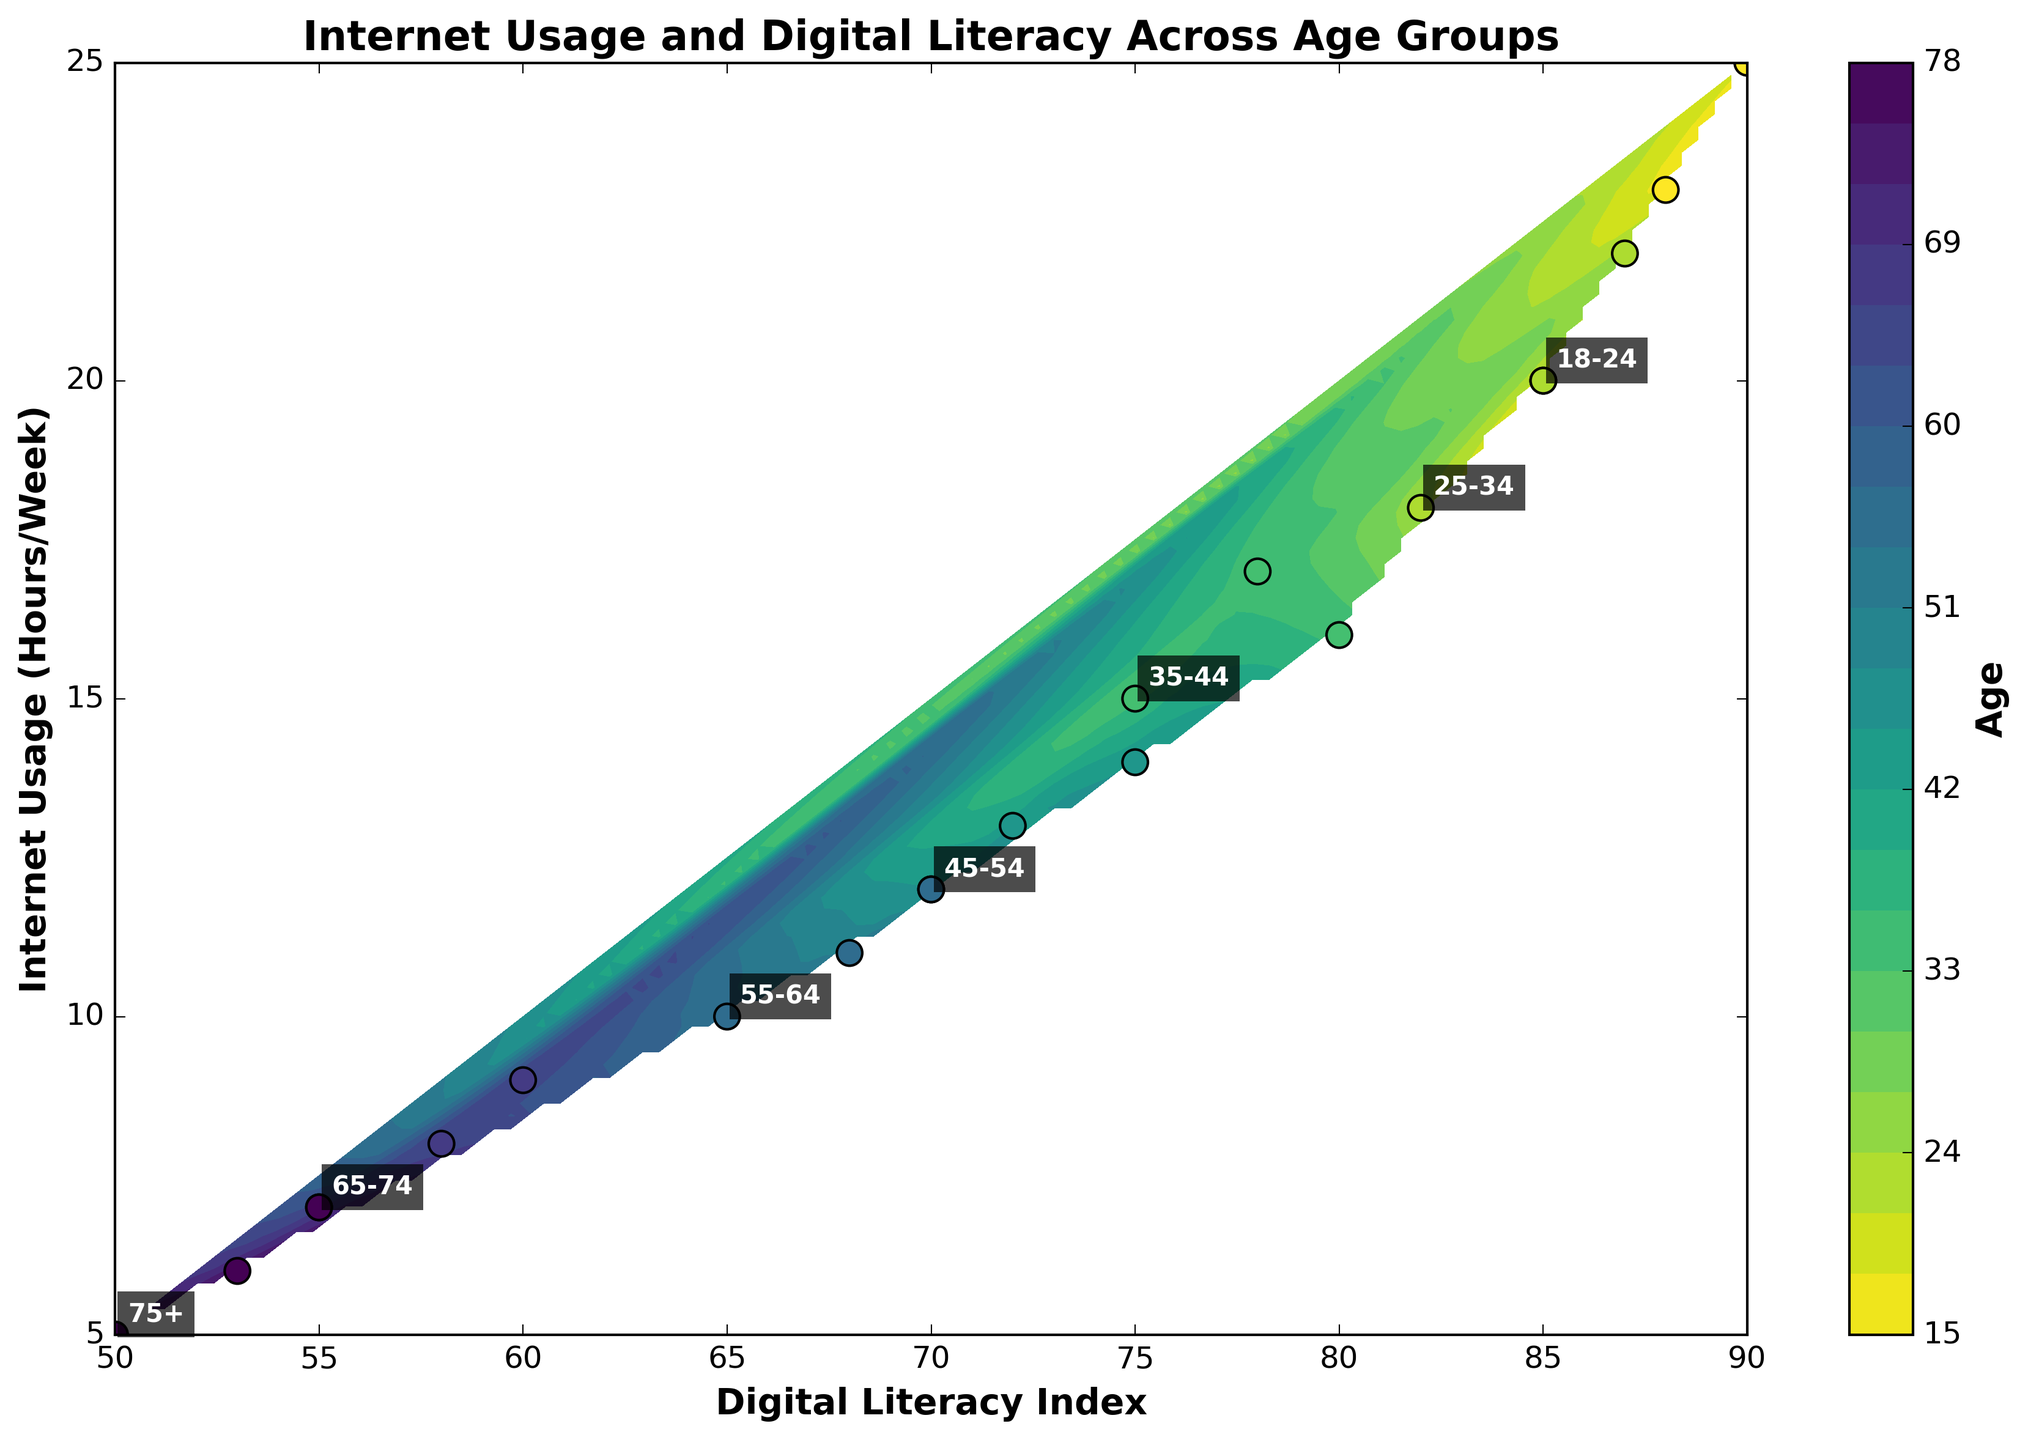What is the title of the figure? The title of the figure is shown at the top of the plot. Here, it states, 'Internet Usage and Digital Literacy Across Age Groups'.
Answer: Internet Usage and Digital Literacy Across Age Groups What are the labels of the X and Y axes? The X-axis label reads 'Digital Literacy Index', and the Y-axis label is 'Internet Usage (Hours/Week)', both located beside their respective axes.
Answer: Digital Literacy Index; Internet Usage (Hours/Week) How many unique age groups are represented in the plot? By examining the annotations on the plot that label different age groups, or by observing the number of unique colors used, the plot shows seven distinct age groups.
Answer: Seven What age group has the highest Digital Literacy Index and how much internet do they use on average weekly? The highest Digital Literacy Index belongs to the '18-24' age group, as seen at the topmost points in the graph. Their internet usage hours per week are clustered around an average of 20 to 25 hours.
Answer: 18-24; 20-25 hours Which age group uses the internet the least per week, and what is their Digital Literacy Index range? The '75+' age group has the least internet usage, around 5-7 hours weekly. Their Digital Literacy Index ranges from 50 to 55, which is evident by the lowest points on the y-axis.
Answer: 75+; 50-55 Which age groups have Digital Literacy Index values between 70 and 80? Observing the X-axis values within the 70 to 80 range, age groups '35-44' and '45-54' fall into this bracket. Their Digital Literacy Index is evident from the spread around this range.
Answer: 35-44; 45-54 Compare the Internet Usage Hours between '18-24' and '65-74' age groups, and which one uses it more? The '18-24' age group has Internet Usage Hours roughly between 20 and 25, while '65-74' age group has between 7 and 9 hours, as visible from their clustered points. The '18-24' group clearly uses the internet more.
Answer: 18-24 What can be observed about the relationship between Digital Literacy Index and Internet Usage across the various age groups? There's a general trend that higher Digital Literacy Index correlates with higher Internet Usage; younger age groups tend to use the internet more and have higher Digital Literacy.
Answer: Higher Literacy → Higher Usage How does the contour plot help in understanding the data distribution across age groups? The contour plot uses color gradients to represent different age brackets, showing how Digital Literacy Index and Internet Usage Hours vary across these groups. The smooth gradient transitions help illustrate overall trends and relationships.
Answer: Shows trends and relationships What does the color of the scatter plot points signify? The colors correlate with the different age groups, which can be inferred from the color bar beside the plot. Each color represents an age group's distribution across Digital Literacy and Internet Usage.
Answer: Age groups 